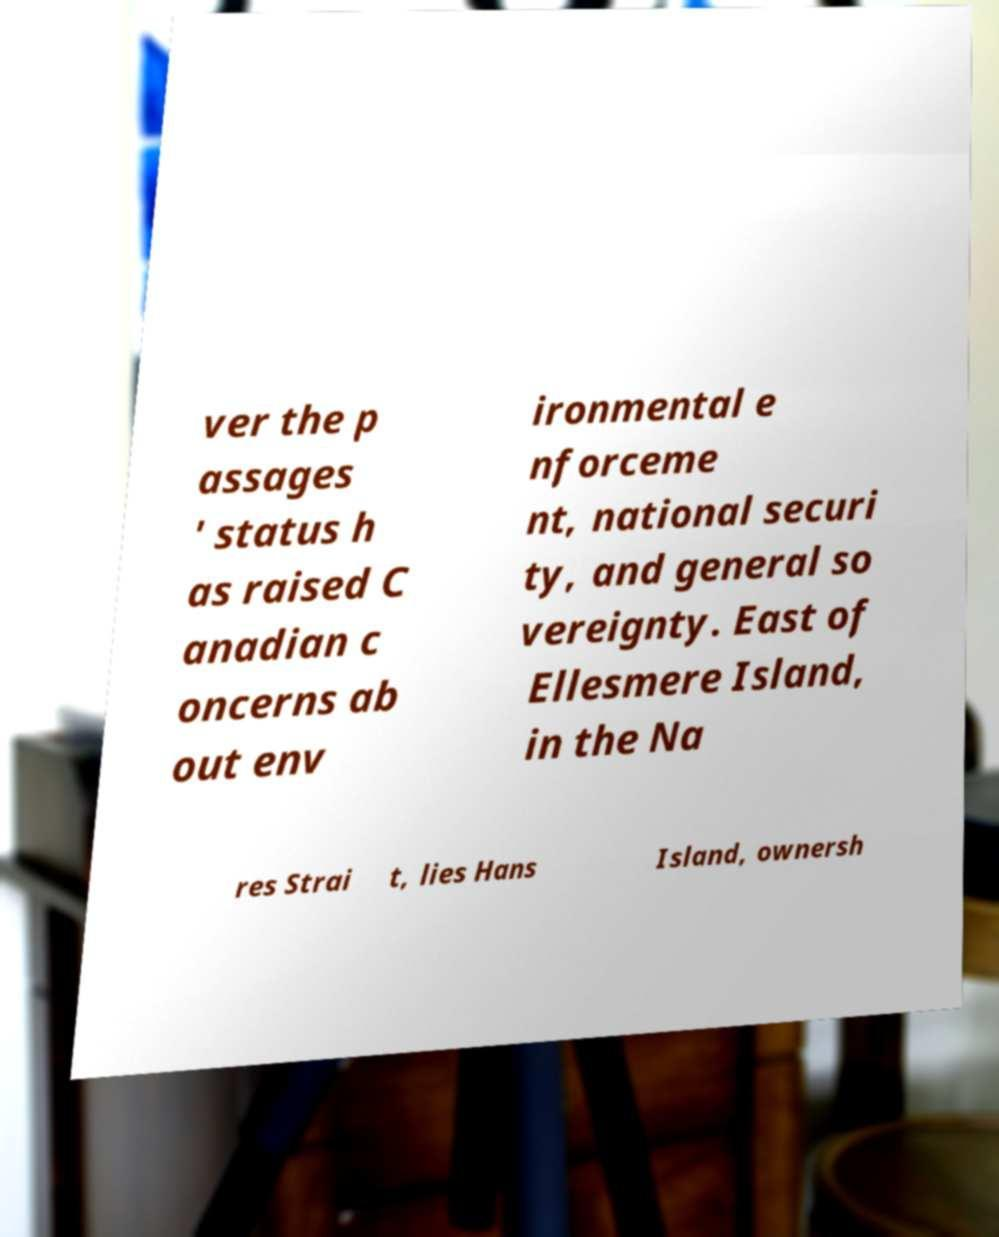What messages or text are displayed in this image? I need them in a readable, typed format. ver the p assages ' status h as raised C anadian c oncerns ab out env ironmental e nforceme nt, national securi ty, and general so vereignty. East of Ellesmere Island, in the Na res Strai t, lies Hans Island, ownersh 